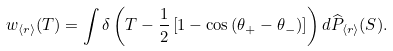Convert formula to latex. <formula><loc_0><loc_0><loc_500><loc_500>w _ { \langle r \rangle } ( T ) = \int \delta \left ( T - \frac { 1 } { 2 } \left [ 1 - \cos \left ( \theta _ { + } - \theta _ { - } \right ) \right ] \right ) d \widehat { P } _ { \langle r \rangle } ( S ) .</formula> 